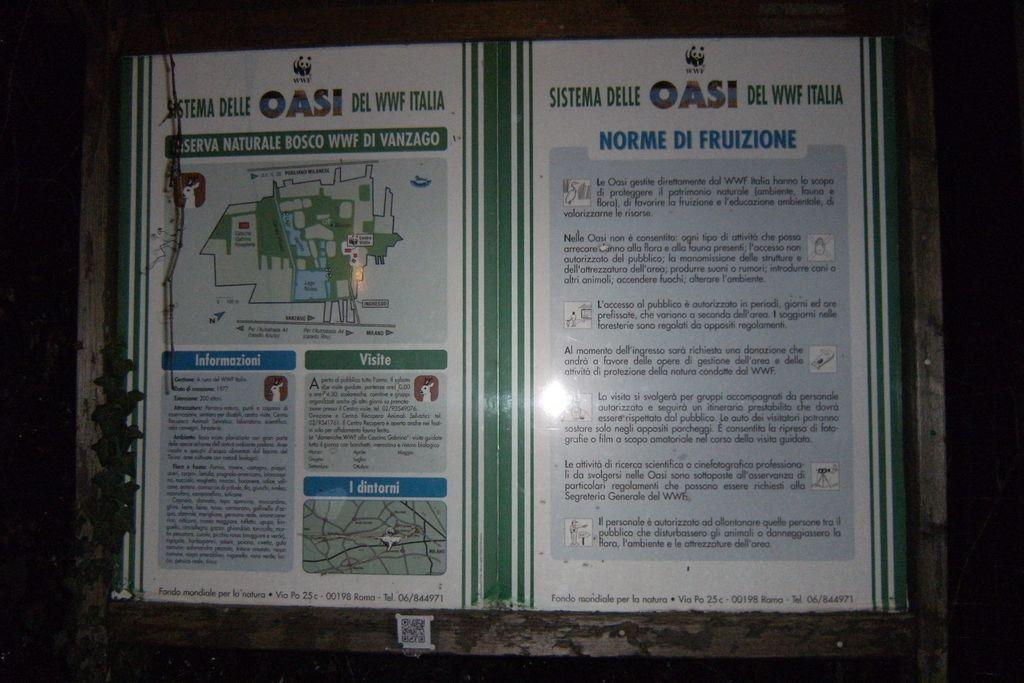<image>
Relay a brief, clear account of the picture shown. a poster that says 'norme de fuizione' on it 